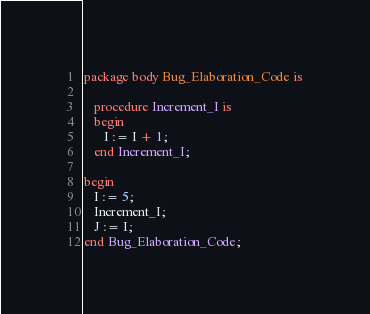<code> <loc_0><loc_0><loc_500><loc_500><_Ada_>package body Bug_Elaboration_Code is

   procedure Increment_I is
   begin
      I := I + 1;
   end Increment_I;

begin
   I := 5;
   Increment_I;
   J := I;
end Bug_Elaboration_Code;
</code> 